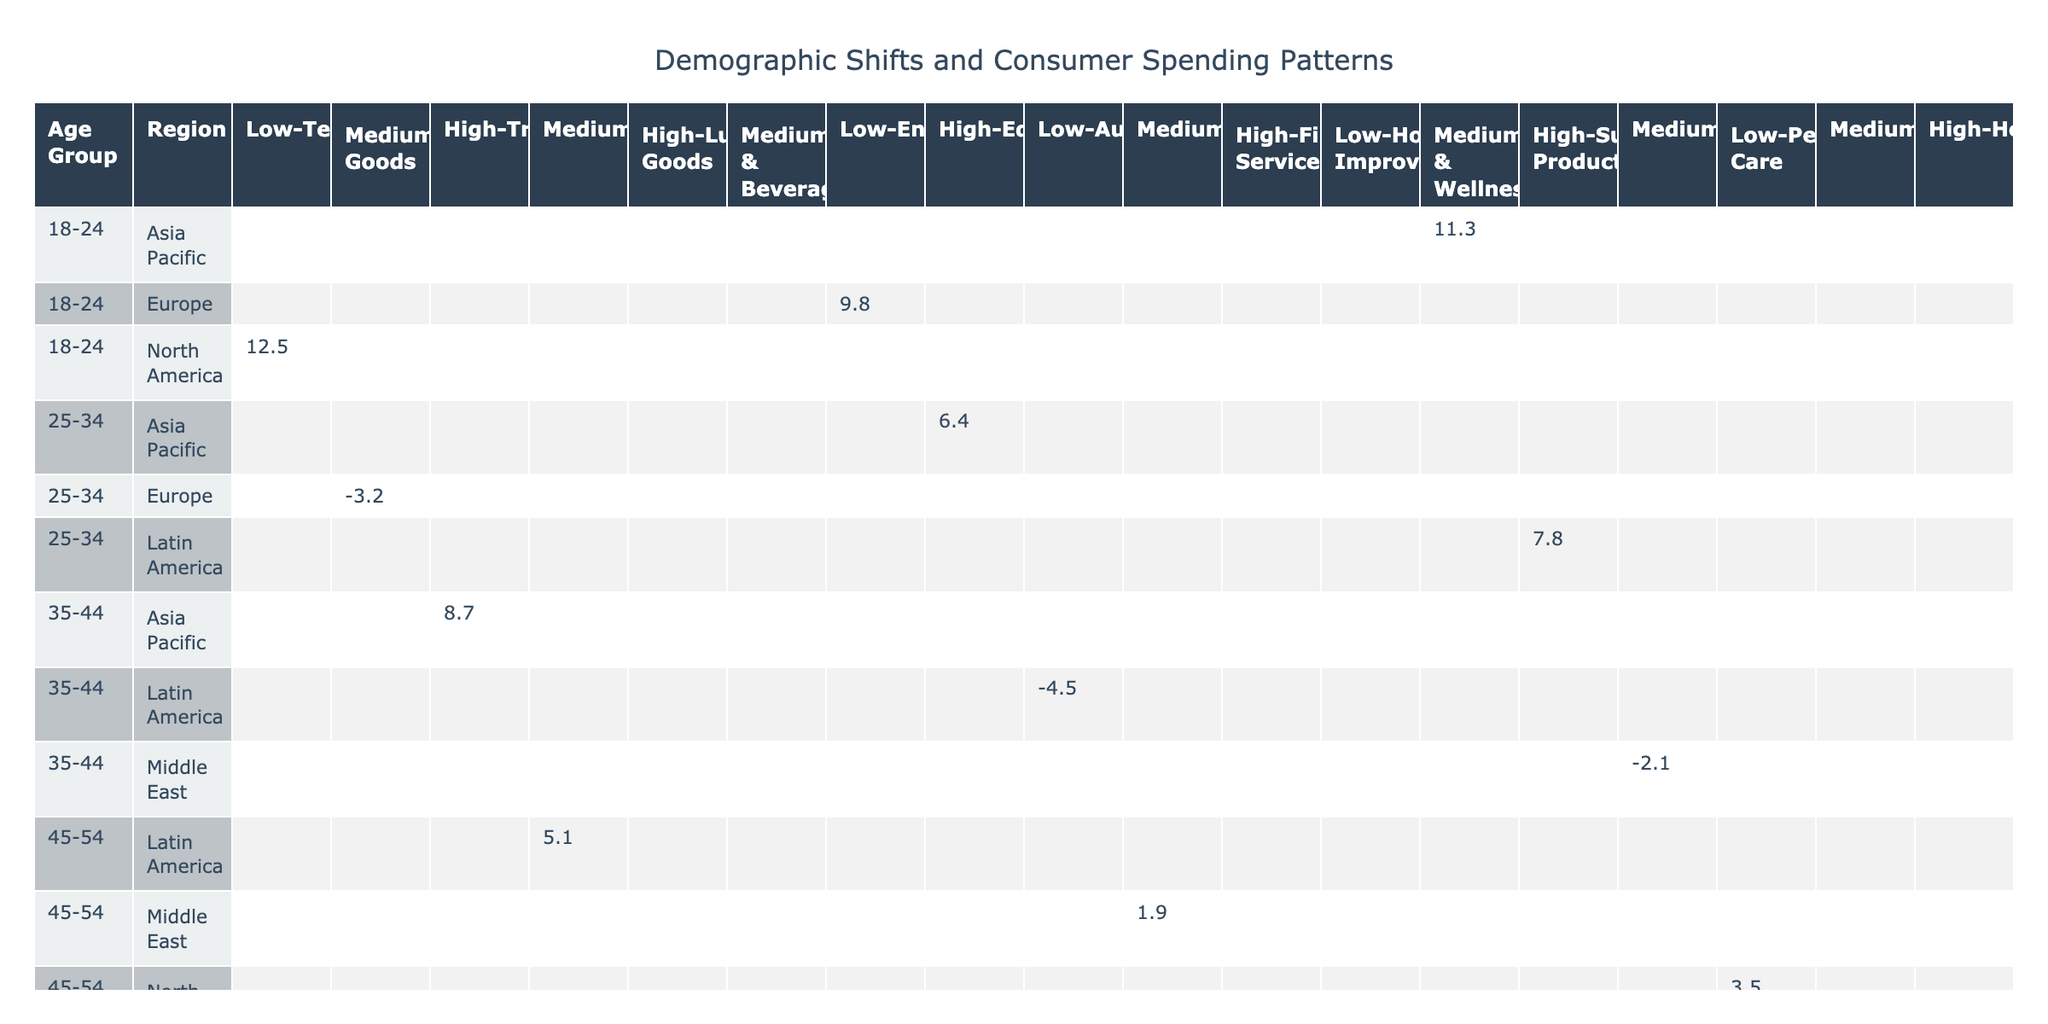What is the percentage change in technology spending for the 18-24 age group in North America? The table shows that the percentage change for technology spending among the 18-24 age group in North America is +12.5.
Answer: +12.5 Which spending category has the highest positive percentage change for the 25-34 age group across all regions? For the 25-34 age group, the spending category with the highest positive percentage change is education in Asia Pacific at +6.4.
Answer: Education in Asia Pacific at +6.4 Is there any spending category where the percentage change is negative for the 55-64 age group in North America? Yes, the spending category for luxury goods in the 55-64 age group in North America has a negative percentage change of -7.6.
Answer: Yes What is the average percentage change in spending for home goods across all regions? The percentage changes for home goods are -3.2 in Europe and 0 in other regions. The average would be (-3.2 + 0) / 2 = -1.6.
Answer: -1.6 Which age group shows the highest percentage change in spending for automotive across all regions? The 35-44 age group has a negative percentage change for automotive at -4.5. No other age group shows a higher negative change than this.
Answer: 35-44 age group at -4.5 For which region does the 65+ age group have the lowest positive percentage change in the food & beverage category? The 65+ age group in North America shows a positive percentage change of +2.3, which is the lowest among the regions listed for this category.
Answer: North America at +2.3 What is the total positive percentage change for spending in sustainable products based on the table? The only data for sustainable products shows a percentage change of +7.8 in the 25-34 age group in Latin America, so the total is +7.8.
Answer: +7.8 In which region and age group is the spending percentage change for fashion highest? The table indicates that the highest percentage change in fashion is for the 45-54 age group in the Middle East at +1.9.
Answer: 45-54 age group in the Middle East at +1.9 What is the difference in percentage change for healthcare spending between the 65+ age groups in Asia Pacific and North America? The percentage change for healthcare spending in the 65+ age group is +9.4 in Asia Pacific and +2.3 in North America. The difference is +9.4 - +2.3 = +7.1.
Answer: +7.1 Is the spending for food & beverage among the 18-24 age group in Europe increasing or decreasing? The table shows the percentage change for food & beverage among the 18-24 age group in Europe is not listed, hence, we cannot determine if it is increasing or decreasing.
Answer: Not applicable (not listed) 